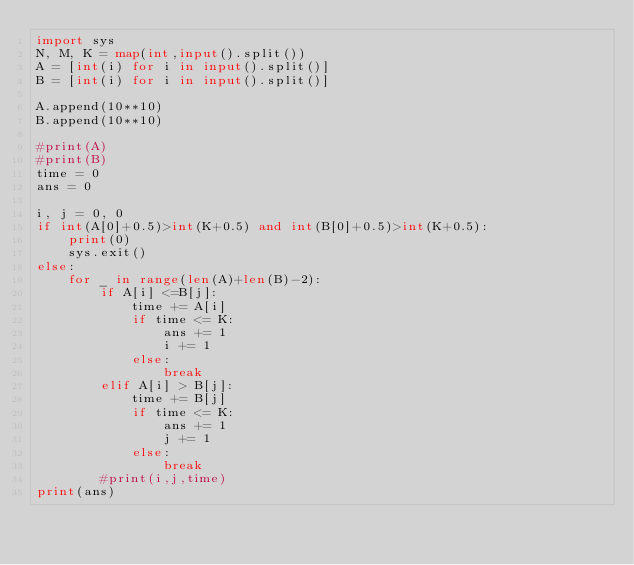Convert code to text. <code><loc_0><loc_0><loc_500><loc_500><_Python_>import sys
N, M, K = map(int,input().split())
A = [int(i) for i in input().split()]
B = [int(i) for i in input().split()]

A.append(10**10)
B.append(10**10)

#print(A)
#print(B)
time = 0
ans = 0

i, j = 0, 0
if int(A[0]+0.5)>int(K+0.5) and int(B[0]+0.5)>int(K+0.5):
    print(0)
    sys.exit()
else:
    for _ in range(len(A)+len(B)-2):
        if A[i] <=B[j]:
            time += A[i]
            if time <= K:
                ans += 1
                i += 1
            else:
                break
        elif A[i] > B[j]:
            time += B[j]
            if time <= K:
                ans += 1
                j += 1
            else:
                break
        #print(i,j,time)
print(ans)</code> 